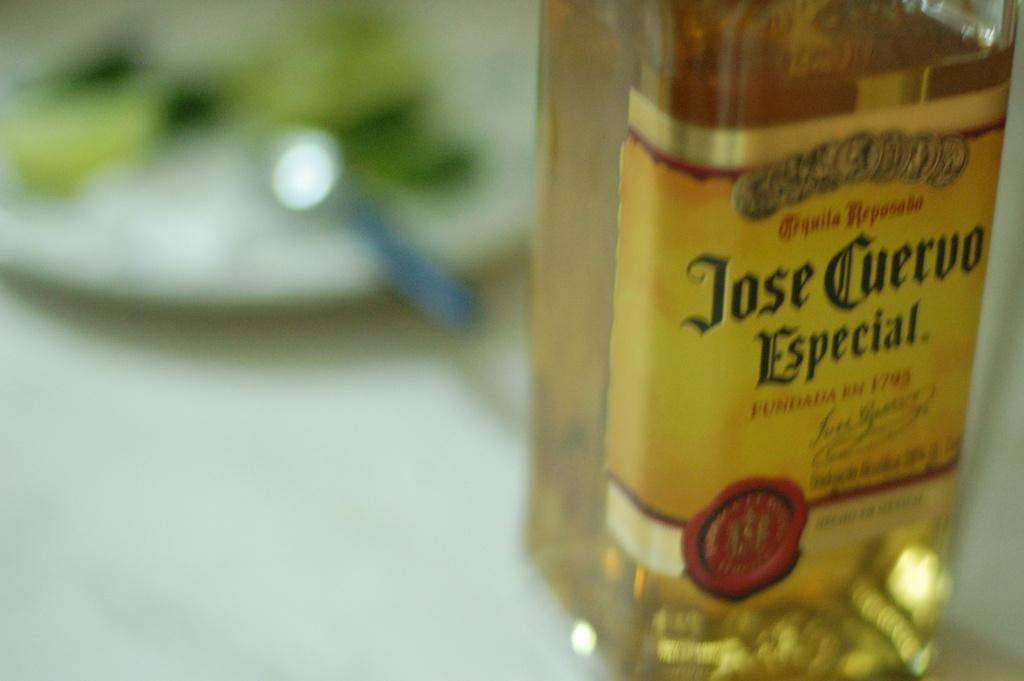<image>
Write a terse but informative summary of the picture. The Jose Cuervo tequila bottle sits next to plate with food on it. 